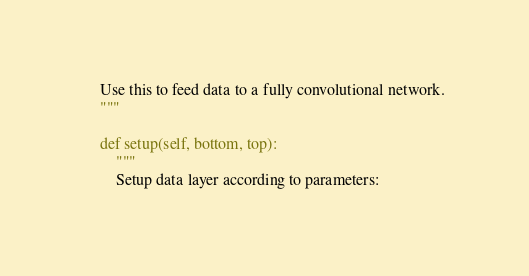<code> <loc_0><loc_0><loc_500><loc_500><_Python_>    Use this to feed data to a fully convolutional network.
    """

    def setup(self, bottom, top):
        """
        Setup data layer according to parameters:
</code> 